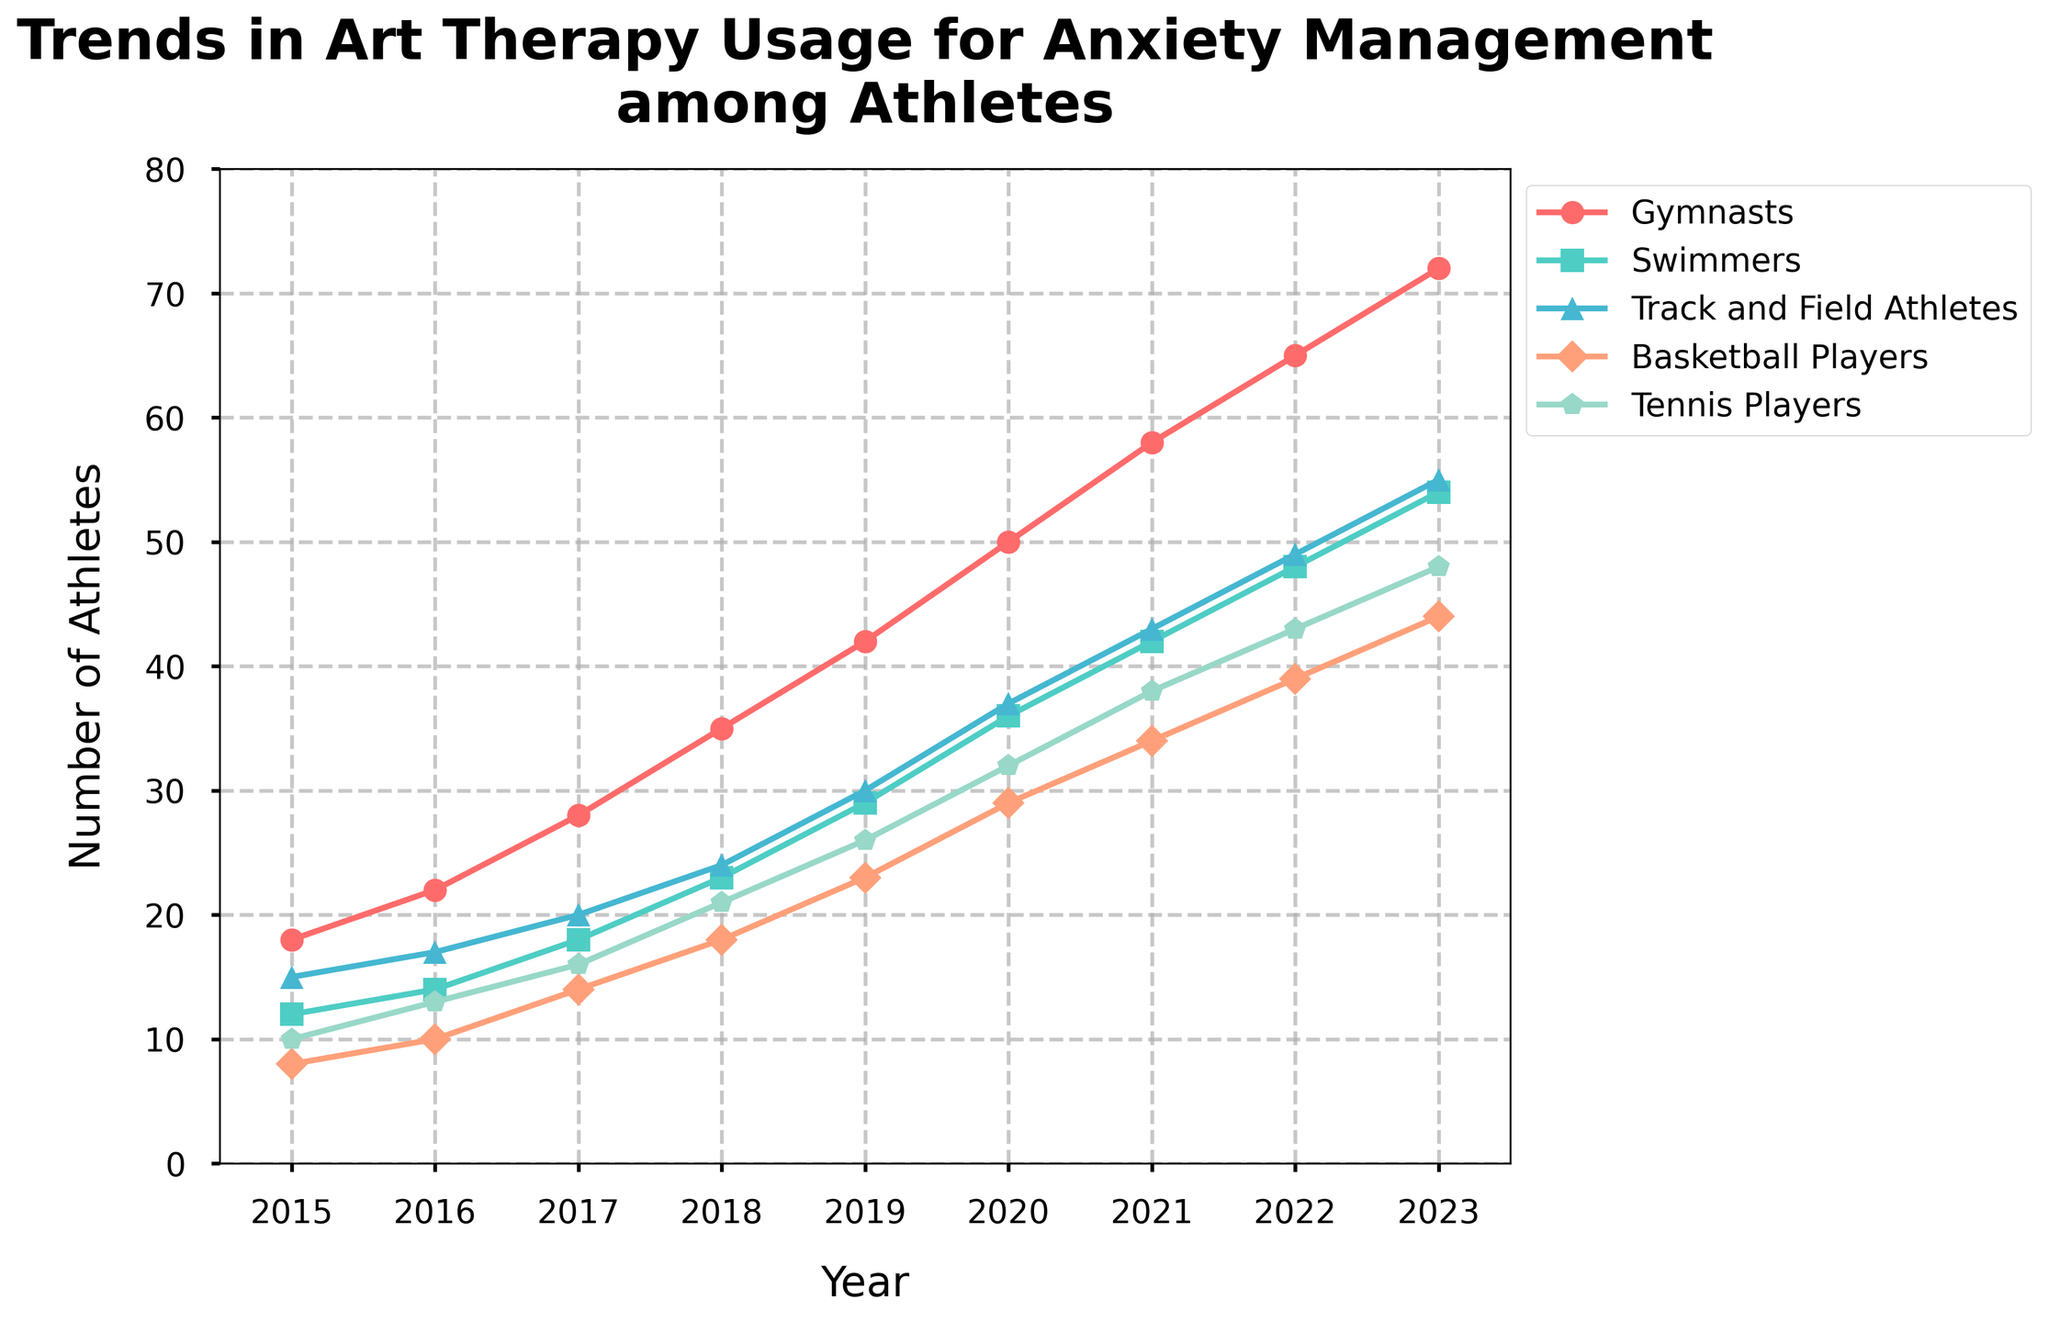What is the trend of art therapy usage among gymnasts from 2015 to 2023? The line representing gymnasts shows a steadily increasing trend from 2015 to 2023, starting at 18 in 2015 and reaching 72 in 2023
Answer: Increasing Trend Which group saw the highest increase in art therapy usage from 2015 to 2023? To determine this, we calculate the difference in values for each group between 2015 and 2023. Gymnasts saw an increase from 18 to 72, swimmers from 12 to 54, track and field athletes from 15 to 55, basketball players from 8 to 44, and tennis players from 10 to 48. Gymnasts experienced the highest increase (72 - 18 = 54)
Answer: Gymnasts What was the average number of basketball players using art therapy from 2015 to 2023? Add the yearly numbers for basketball players: 8, 10, 14, 18, 23, 29, 34, 39, 44; sum is 219. Then divide by the number of years (9): 219/9
Answer: 24.33 Which two groups had the closest usage numbers in 2020, and what are those numbers? In 2020, the values for each group are: gymnasts (50), swimmers (36), track and field athletes (37), basketball players (29), tennis players (32). We compare these numbers to find the closest pair: 36 (swimmers) and 37 (track and field athletes) are closest
Answer: Swimmers and Track and Field Athletes; 36 and 37 What is the total number of athletes who used art therapy across all groups in 2021? Sum the values for all groups in 2021: 58 (gymnasts) + 42 (swimmers) + 43 (track and field athletes) + 34 (basketball players) + 38 (tennis players) = 215
Answer: 215 Between which years did swimmers see the largest increase in art therapy usage? Check the difference for each consecutive year for swimmers: (14-12), (18-14), (23-18), (29-23), (36-29), (42-36), (48-42), (54-48). The largest increase is between 2017 and 2018, where the difference is 5 units
Answer: 2017-2018 How many track and field athletes used art therapy in 2019 compared to tennis players in the same year? In 2019, track and field athletes have 30 and tennis players have 26 using art therapy
Answer: Track and Field Athletes: 30, Tennis Players: 26 What color represents the line for tennis players in the chart? The visual attribute of the chart shows that the line representing tennis players is depicted in green
Answer: Green 